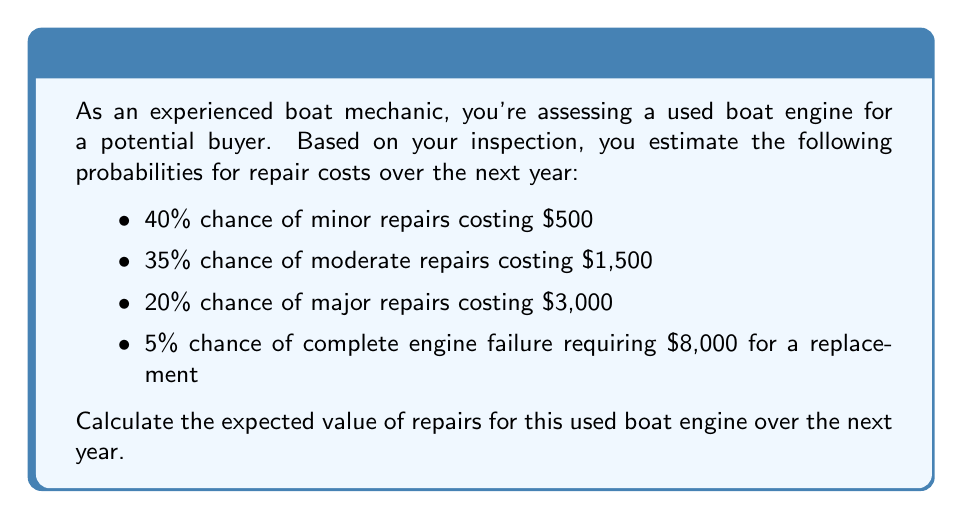Help me with this question. To calculate the expected value, we need to multiply each possible outcome by its probability and then sum these products. Let's break it down step-by-step:

1) For minor repairs:
   $0.40 \times \$500 = \$200$

2) For moderate repairs:
   $0.35 \times \$1,500 = \$525$

3) For major repairs:
   $0.20 \times \$3,000 = \$600$

4) For complete engine failure:
   $0.05 \times \$8,000 = \$400$

Now, we sum these values:

$$\text{Expected Value} = \$200 + \$525 + \$600 + \$400 = \$1,725$$

Therefore, the expected value of repairs for this used boat engine over the next year is $1,725.
Answer: $1,725 